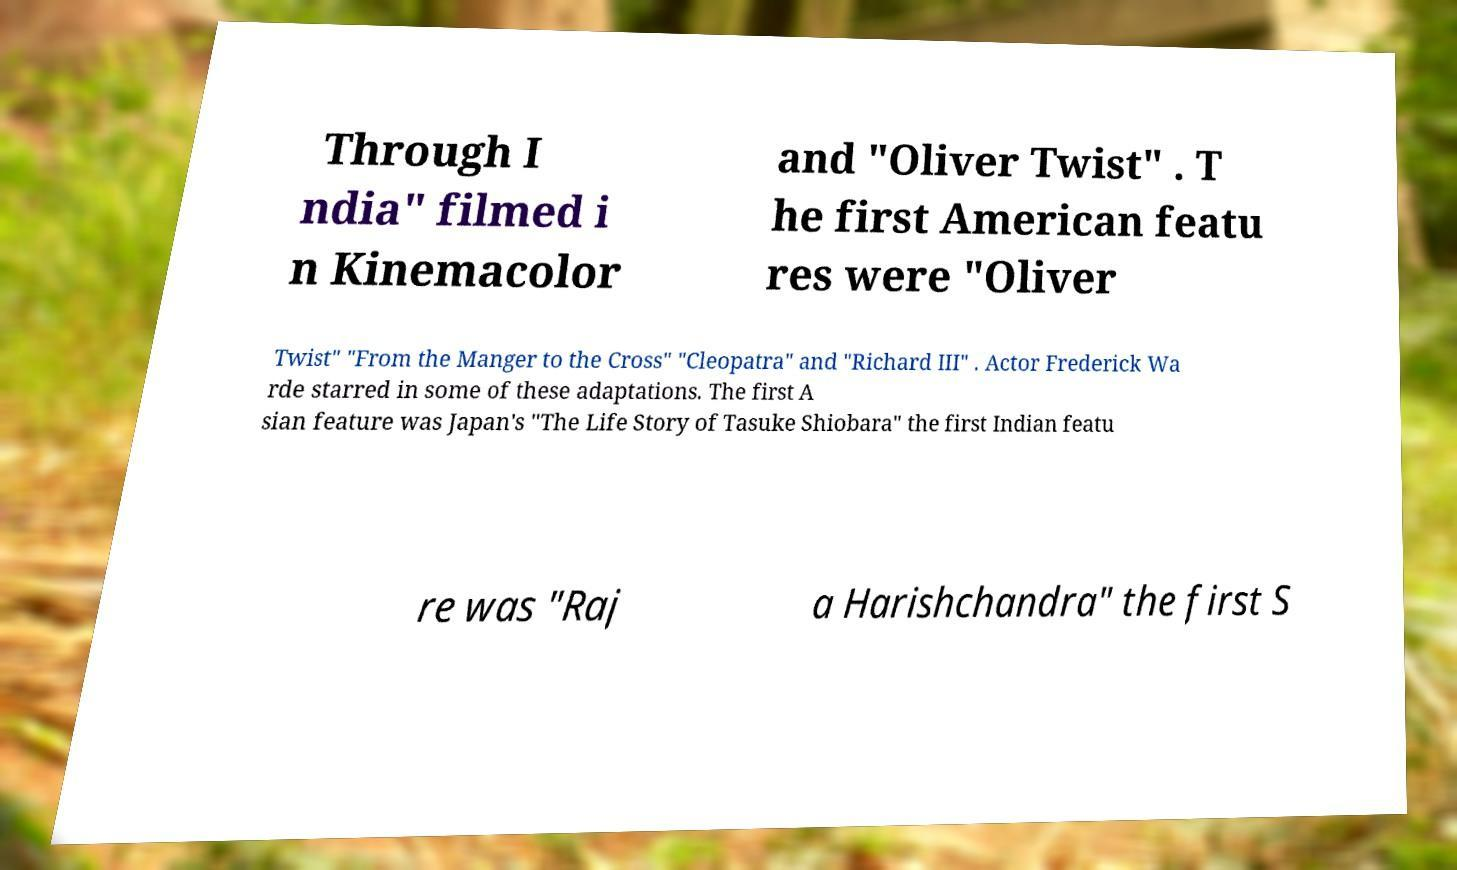For documentation purposes, I need the text within this image transcribed. Could you provide that? Through I ndia" filmed i n Kinemacolor and "Oliver Twist" . T he first American featu res were "Oliver Twist" "From the Manger to the Cross" "Cleopatra" and "Richard III" . Actor Frederick Wa rde starred in some of these adaptations. The first A sian feature was Japan's "The Life Story of Tasuke Shiobara" the first Indian featu re was "Raj a Harishchandra" the first S 